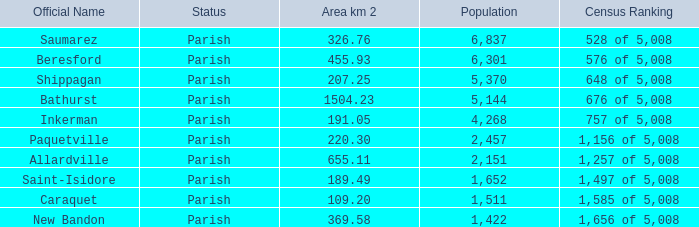76 km²? 1422.0. 